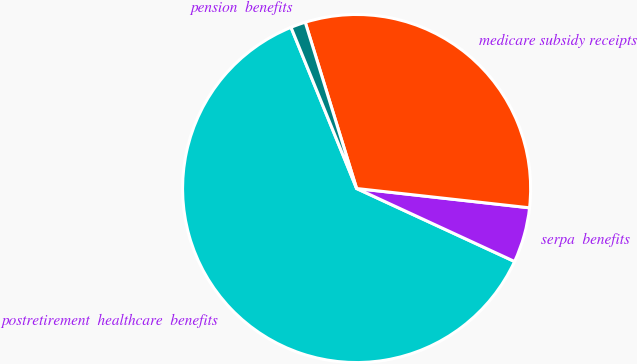<chart> <loc_0><loc_0><loc_500><loc_500><pie_chart><fcel>postretirement  healthcare  benefits<fcel>serpa  benefits<fcel>medicare subsidy receipts<fcel>pension  benefits<nl><fcel>61.96%<fcel>5.12%<fcel>31.54%<fcel>1.38%<nl></chart> 